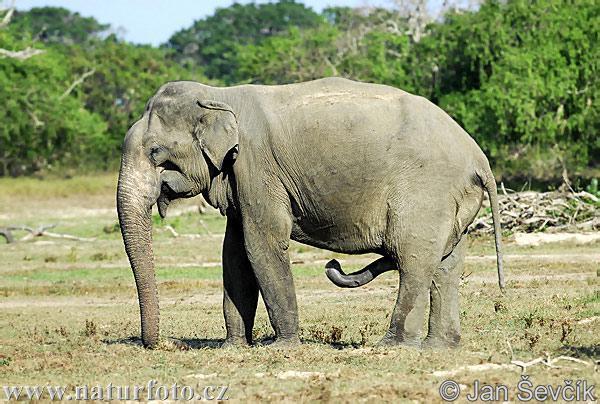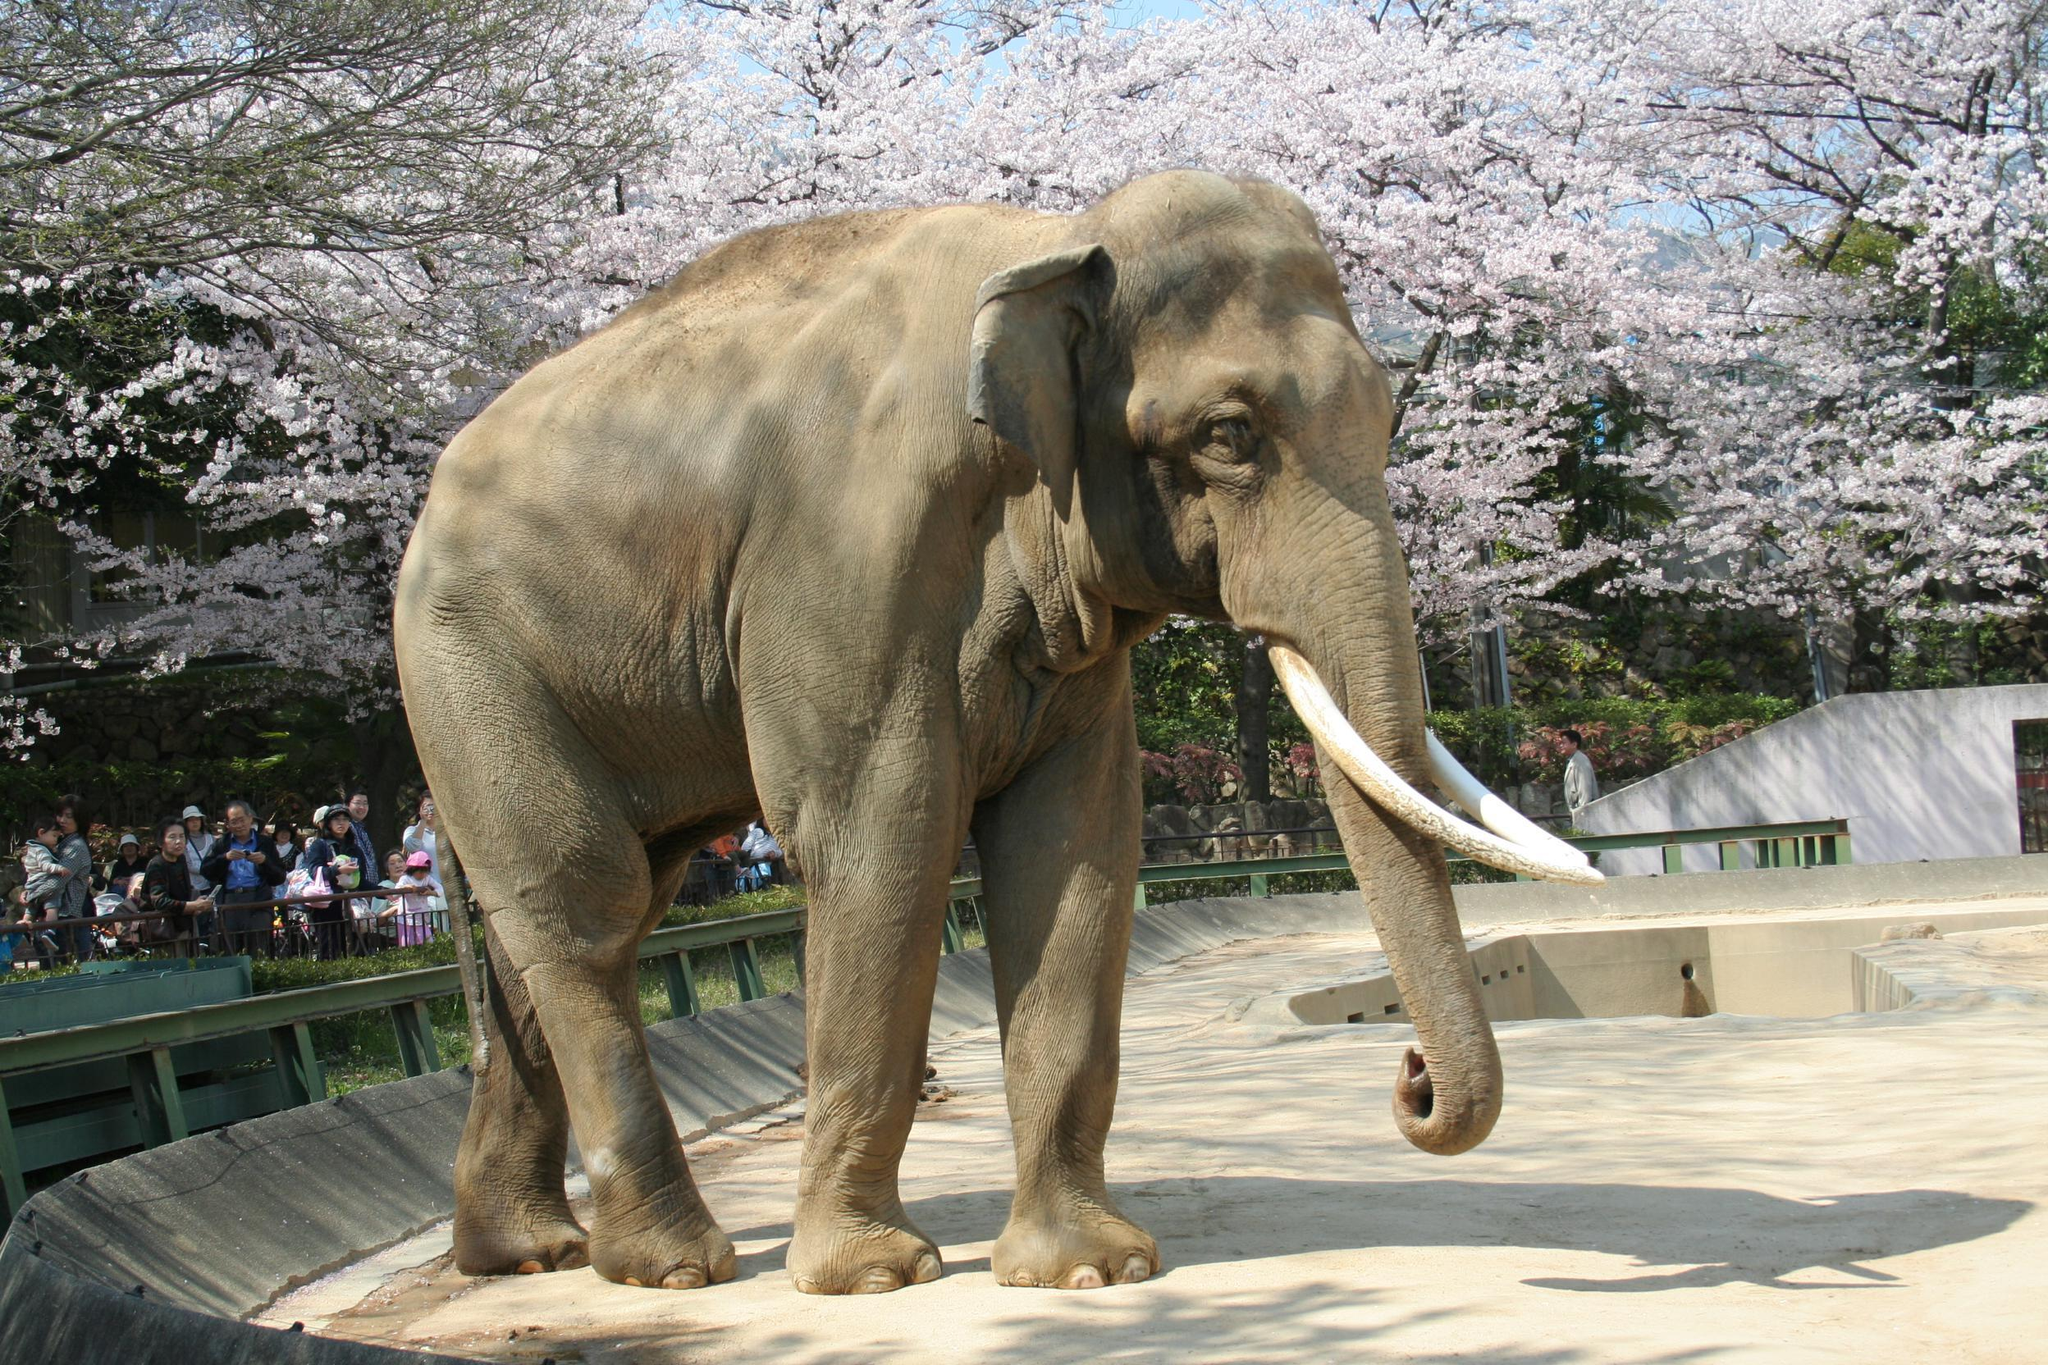The first image is the image on the left, the second image is the image on the right. Analyze the images presented: Is the assertion "the elephant on the right image is facing right." valid? Answer yes or no. Yes. 